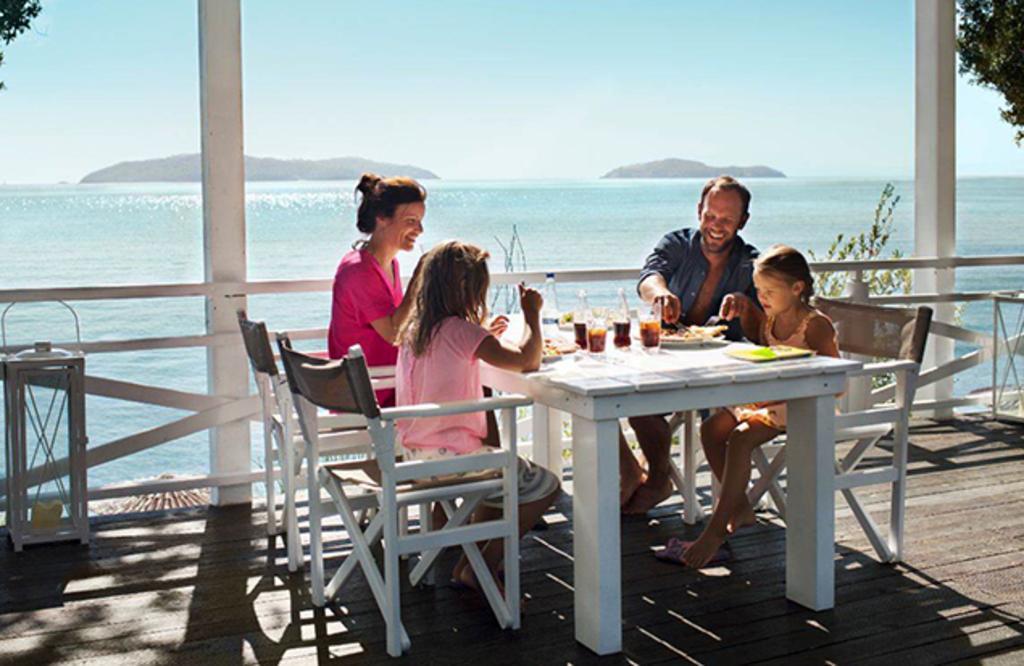How would you summarize this image in a sentence or two? This is a freshwater river. Far there are mountains. This is plant. These persons are sitting on a chair. In-front of this person there is a table, on a table there is a plate, bottle and glasses. These two persons are holding a smile. 